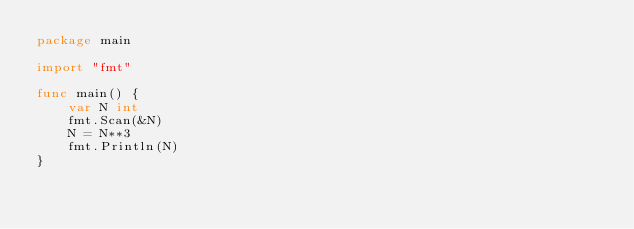<code> <loc_0><loc_0><loc_500><loc_500><_Go_>package main

import "fmt"

func main() {
	var N int
	fmt.Scan(&N)
	N = N**3
	fmt.Println(N)
}</code> 